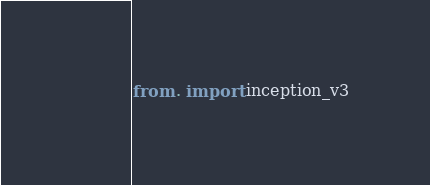<code> <loc_0><loc_0><loc_500><loc_500><_Python_>from . import inception_v3</code> 